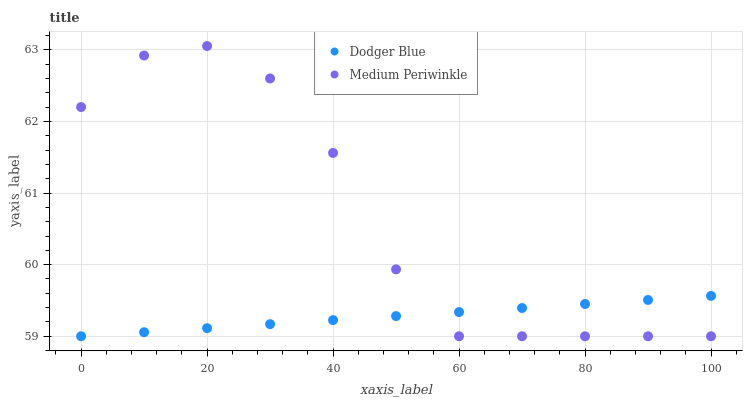Does Dodger Blue have the minimum area under the curve?
Answer yes or no. Yes. Does Medium Periwinkle have the maximum area under the curve?
Answer yes or no. Yes. Does Dodger Blue have the maximum area under the curve?
Answer yes or no. No. Is Dodger Blue the smoothest?
Answer yes or no. Yes. Is Medium Periwinkle the roughest?
Answer yes or no. Yes. Is Dodger Blue the roughest?
Answer yes or no. No. Does Medium Periwinkle have the lowest value?
Answer yes or no. Yes. Does Medium Periwinkle have the highest value?
Answer yes or no. Yes. Does Dodger Blue have the highest value?
Answer yes or no. No. Does Dodger Blue intersect Medium Periwinkle?
Answer yes or no. Yes. Is Dodger Blue less than Medium Periwinkle?
Answer yes or no. No. Is Dodger Blue greater than Medium Periwinkle?
Answer yes or no. No. 